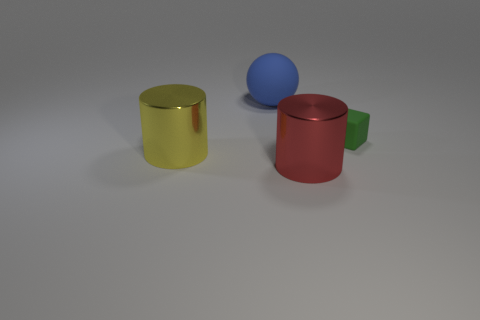Is there a small gray shiny cylinder?
Your response must be concise. No. How many small rubber things are on the left side of the shiny cylinder left of the metallic cylinder on the right side of the large matte object?
Make the answer very short. 0. Is the shape of the small green rubber object the same as the rubber object on the left side of the small green block?
Keep it short and to the point. No. Are there more tiny green matte blocks than brown matte cylinders?
Your answer should be very brief. Yes. Is there any other thing that has the same size as the matte cube?
Offer a very short reply. No. There is a large shiny thing that is to the right of the matte sphere; is it the same shape as the big yellow object?
Give a very brief answer. Yes. Is the number of cylinders left of the red cylinder greater than the number of tiny gray matte cylinders?
Provide a succinct answer. Yes. There is a metallic cylinder to the left of the rubber object that is to the left of the cube; what color is it?
Offer a very short reply. Yellow. What number of tiny cubes are there?
Keep it short and to the point. 1. How many things are both behind the yellow metallic cylinder and left of the rubber cube?
Keep it short and to the point. 1. 